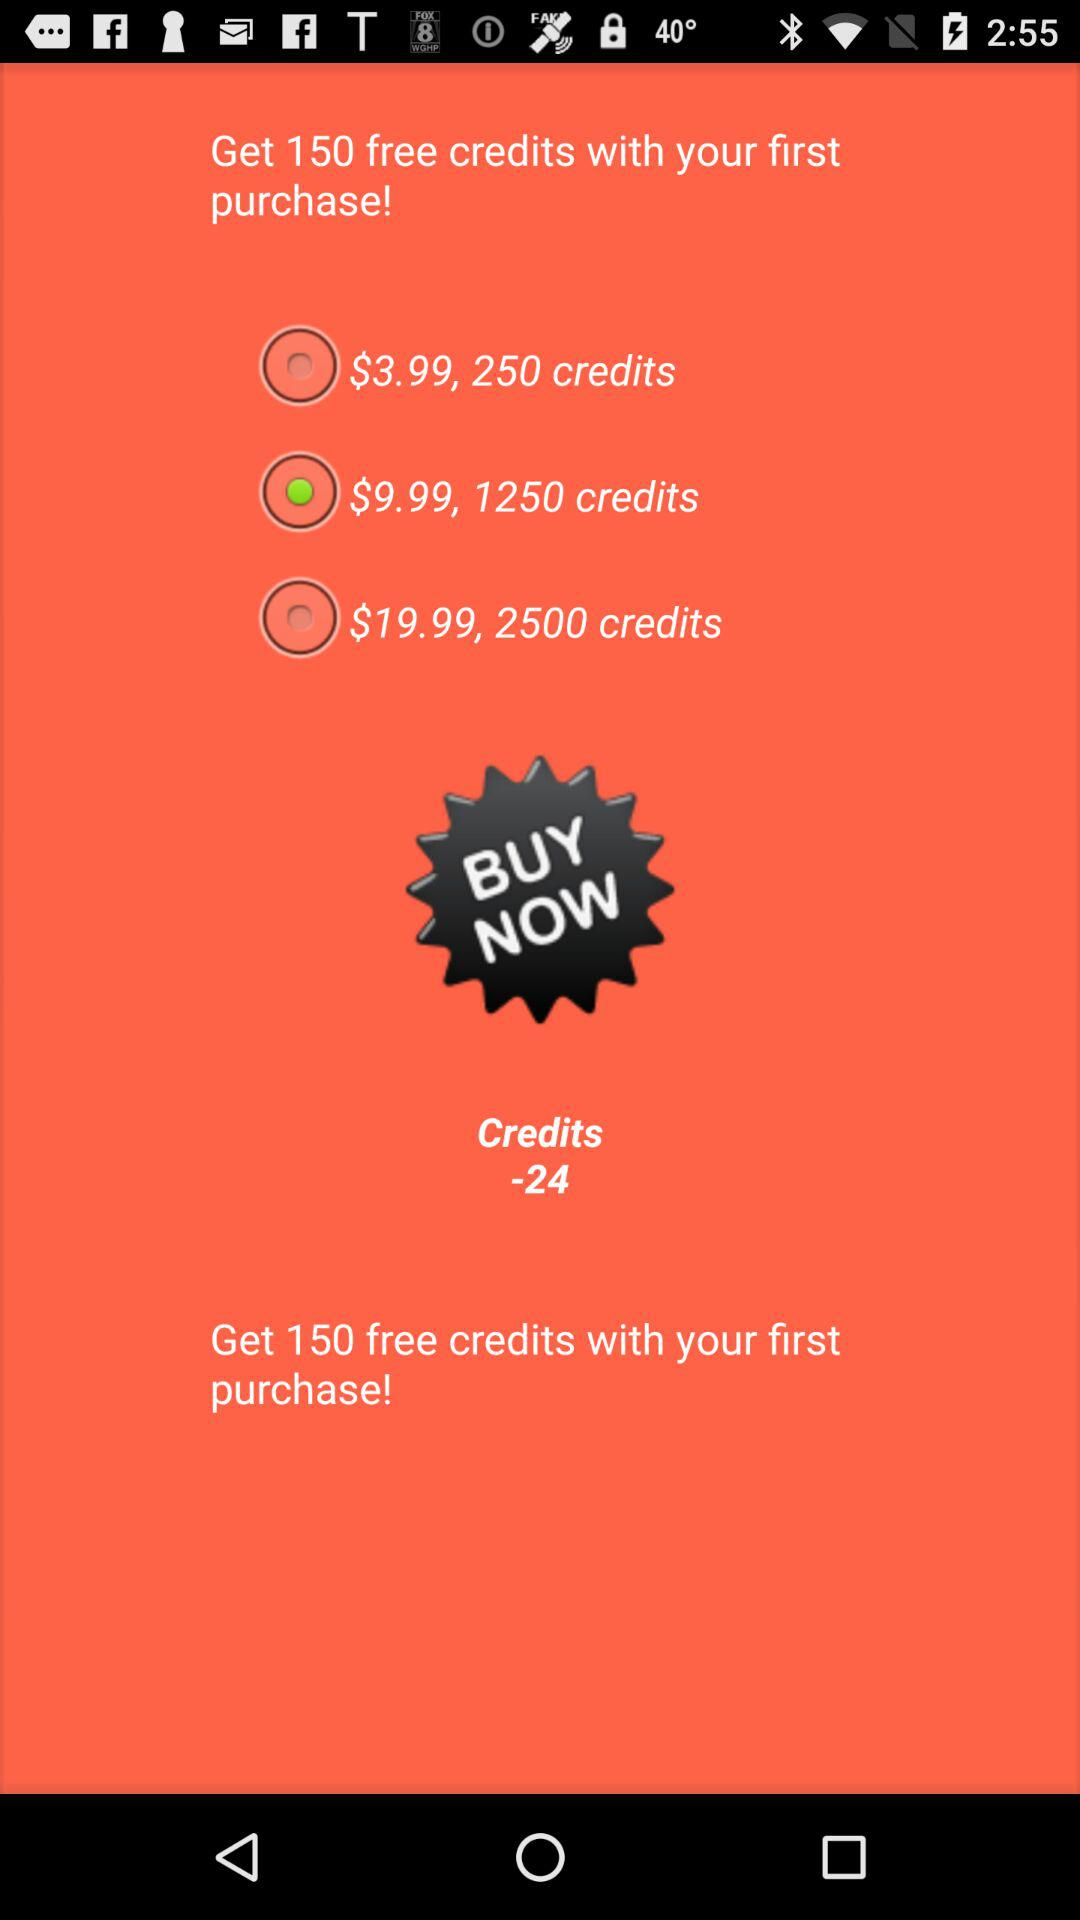How many credits do you get for the $19.99 option?
Answer the question using a single word or phrase. 2500 